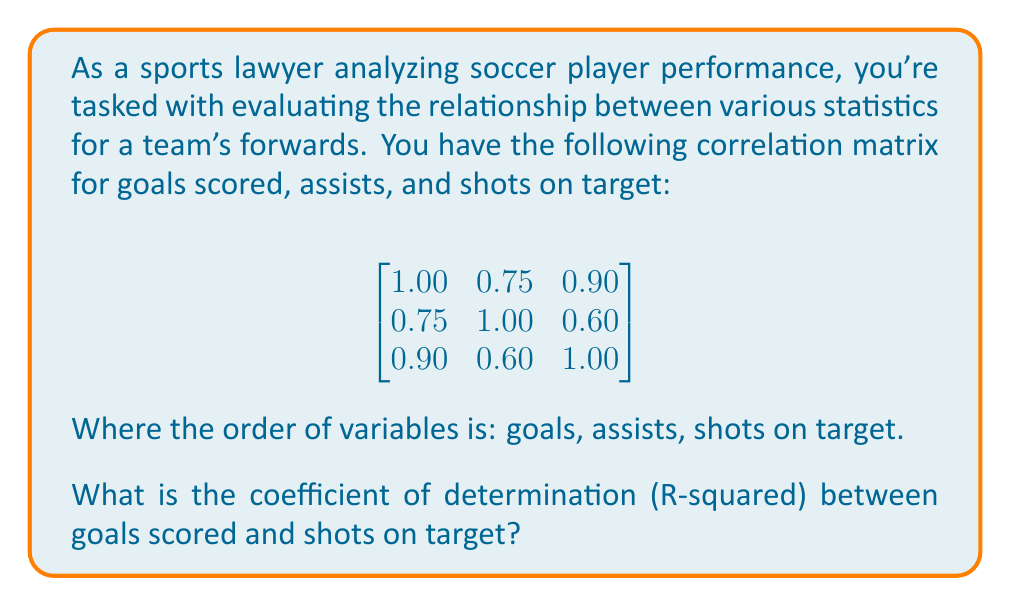Show me your answer to this math problem. To solve this problem, we need to follow these steps:

1. Identify the correlation coefficient between goals scored and shots on target.
2. Square the correlation coefficient to get the coefficient of determination (R-squared).

Step 1: Identifying the correlation coefficient
The correlation coefficient between goals scored and shots on target can be found in the correlation matrix. It's the value in the first row, third column (or third row, first column, as the matrix is symmetric): 0.90.

Step 2: Calculating R-squared
The coefficient of determination (R-squared) is the square of the correlation coefficient.

$$ R^2 = (0.90)^2 = 0.81 $$

Therefore, the coefficient of determination between goals scored and shots on target is 0.81 or 81%.

This means that 81% of the variance in goals scored can be explained by the variance in shots on target, indicating a strong relationship between these two variables.
Answer: 0.81 